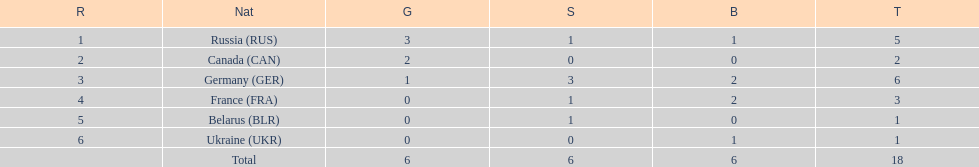What was the total number of silver medals awarded to the french and the germans in the 1994 winter olympic biathlon? 4. 